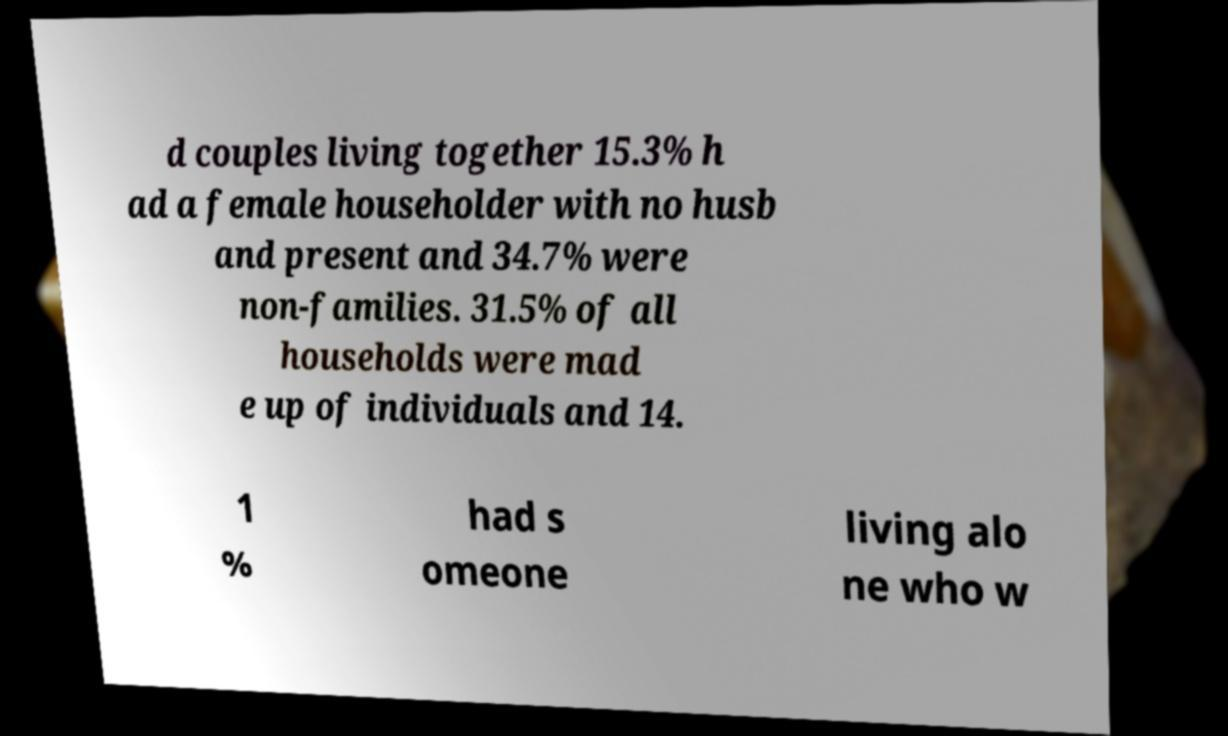Can you accurately transcribe the text from the provided image for me? d couples living together 15.3% h ad a female householder with no husb and present and 34.7% were non-families. 31.5% of all households were mad e up of individuals and 14. 1 % had s omeone living alo ne who w 